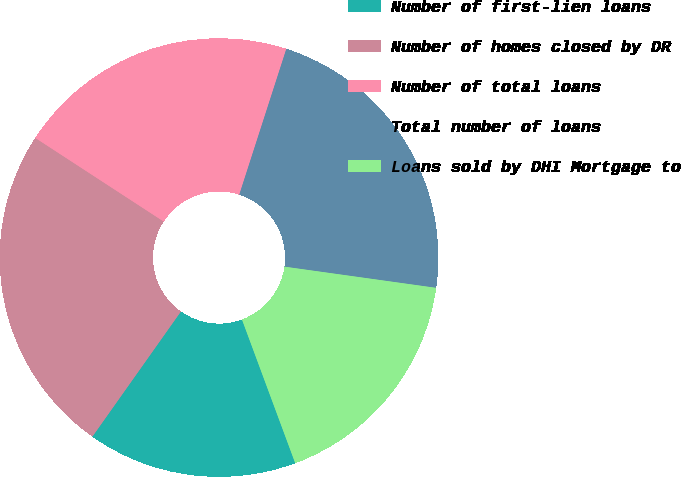Convert chart. <chart><loc_0><loc_0><loc_500><loc_500><pie_chart><fcel>Number of first-lien loans<fcel>Number of homes closed by DR<fcel>Number of total loans<fcel>Total number of loans<fcel>Loans sold by DHI Mortgage to<nl><fcel>15.45%<fcel>24.39%<fcel>20.78%<fcel>22.24%<fcel>17.14%<nl></chart> 